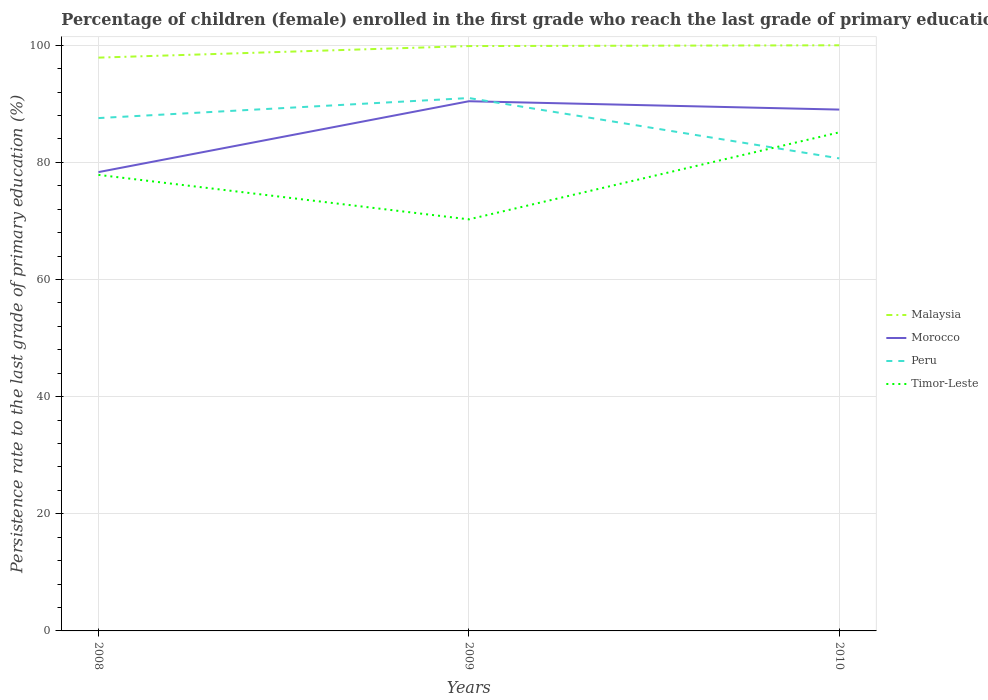Does the line corresponding to Peru intersect with the line corresponding to Malaysia?
Provide a succinct answer. No. Across all years, what is the maximum persistence rate of children in Morocco?
Provide a succinct answer. 78.34. What is the total persistence rate of children in Timor-Leste in the graph?
Provide a succinct answer. -14.86. What is the difference between the highest and the second highest persistence rate of children in Peru?
Your answer should be very brief. 10.3. What is the difference between the highest and the lowest persistence rate of children in Peru?
Provide a short and direct response. 2. Is the persistence rate of children in Peru strictly greater than the persistence rate of children in Morocco over the years?
Ensure brevity in your answer.  No. How many lines are there?
Ensure brevity in your answer.  4. Does the graph contain any zero values?
Provide a short and direct response. No. Where does the legend appear in the graph?
Provide a succinct answer. Center right. How many legend labels are there?
Ensure brevity in your answer.  4. How are the legend labels stacked?
Your answer should be compact. Vertical. What is the title of the graph?
Offer a very short reply. Percentage of children (female) enrolled in the first grade who reach the last grade of primary education. What is the label or title of the X-axis?
Your answer should be very brief. Years. What is the label or title of the Y-axis?
Give a very brief answer. Persistence rate to the last grade of primary education (%). What is the Persistence rate to the last grade of primary education (%) of Malaysia in 2008?
Give a very brief answer. 97.89. What is the Persistence rate to the last grade of primary education (%) of Morocco in 2008?
Your answer should be very brief. 78.34. What is the Persistence rate to the last grade of primary education (%) of Peru in 2008?
Give a very brief answer. 87.57. What is the Persistence rate to the last grade of primary education (%) of Timor-Leste in 2008?
Your answer should be compact. 77.87. What is the Persistence rate to the last grade of primary education (%) in Malaysia in 2009?
Provide a succinct answer. 99.87. What is the Persistence rate to the last grade of primary education (%) in Morocco in 2009?
Provide a short and direct response. 90.44. What is the Persistence rate to the last grade of primary education (%) of Peru in 2009?
Make the answer very short. 90.99. What is the Persistence rate to the last grade of primary education (%) in Timor-Leste in 2009?
Offer a terse response. 70.28. What is the Persistence rate to the last grade of primary education (%) of Morocco in 2010?
Your response must be concise. 89.02. What is the Persistence rate to the last grade of primary education (%) in Peru in 2010?
Offer a terse response. 80.69. What is the Persistence rate to the last grade of primary education (%) in Timor-Leste in 2010?
Make the answer very short. 85.14. Across all years, what is the maximum Persistence rate to the last grade of primary education (%) in Morocco?
Your response must be concise. 90.44. Across all years, what is the maximum Persistence rate to the last grade of primary education (%) in Peru?
Make the answer very short. 90.99. Across all years, what is the maximum Persistence rate to the last grade of primary education (%) of Timor-Leste?
Your answer should be compact. 85.14. Across all years, what is the minimum Persistence rate to the last grade of primary education (%) of Malaysia?
Provide a short and direct response. 97.89. Across all years, what is the minimum Persistence rate to the last grade of primary education (%) of Morocco?
Your answer should be very brief. 78.34. Across all years, what is the minimum Persistence rate to the last grade of primary education (%) in Peru?
Keep it short and to the point. 80.69. Across all years, what is the minimum Persistence rate to the last grade of primary education (%) in Timor-Leste?
Ensure brevity in your answer.  70.28. What is the total Persistence rate to the last grade of primary education (%) in Malaysia in the graph?
Give a very brief answer. 297.76. What is the total Persistence rate to the last grade of primary education (%) in Morocco in the graph?
Keep it short and to the point. 257.81. What is the total Persistence rate to the last grade of primary education (%) in Peru in the graph?
Keep it short and to the point. 259.25. What is the total Persistence rate to the last grade of primary education (%) in Timor-Leste in the graph?
Offer a terse response. 233.28. What is the difference between the Persistence rate to the last grade of primary education (%) in Malaysia in 2008 and that in 2009?
Provide a succinct answer. -1.97. What is the difference between the Persistence rate to the last grade of primary education (%) in Morocco in 2008 and that in 2009?
Offer a very short reply. -12.1. What is the difference between the Persistence rate to the last grade of primary education (%) in Peru in 2008 and that in 2009?
Keep it short and to the point. -3.42. What is the difference between the Persistence rate to the last grade of primary education (%) in Timor-Leste in 2008 and that in 2009?
Make the answer very short. 7.6. What is the difference between the Persistence rate to the last grade of primary education (%) of Malaysia in 2008 and that in 2010?
Ensure brevity in your answer.  -2.11. What is the difference between the Persistence rate to the last grade of primary education (%) of Morocco in 2008 and that in 2010?
Your answer should be compact. -10.68. What is the difference between the Persistence rate to the last grade of primary education (%) in Peru in 2008 and that in 2010?
Offer a terse response. 6.88. What is the difference between the Persistence rate to the last grade of primary education (%) in Timor-Leste in 2008 and that in 2010?
Your response must be concise. -7.26. What is the difference between the Persistence rate to the last grade of primary education (%) in Malaysia in 2009 and that in 2010?
Give a very brief answer. -0.13. What is the difference between the Persistence rate to the last grade of primary education (%) in Morocco in 2009 and that in 2010?
Your answer should be very brief. 1.42. What is the difference between the Persistence rate to the last grade of primary education (%) in Peru in 2009 and that in 2010?
Offer a terse response. 10.3. What is the difference between the Persistence rate to the last grade of primary education (%) of Timor-Leste in 2009 and that in 2010?
Keep it short and to the point. -14.86. What is the difference between the Persistence rate to the last grade of primary education (%) of Malaysia in 2008 and the Persistence rate to the last grade of primary education (%) of Morocco in 2009?
Provide a short and direct response. 7.45. What is the difference between the Persistence rate to the last grade of primary education (%) of Malaysia in 2008 and the Persistence rate to the last grade of primary education (%) of Peru in 2009?
Provide a succinct answer. 6.9. What is the difference between the Persistence rate to the last grade of primary education (%) in Malaysia in 2008 and the Persistence rate to the last grade of primary education (%) in Timor-Leste in 2009?
Make the answer very short. 27.62. What is the difference between the Persistence rate to the last grade of primary education (%) of Morocco in 2008 and the Persistence rate to the last grade of primary education (%) of Peru in 2009?
Keep it short and to the point. -12.65. What is the difference between the Persistence rate to the last grade of primary education (%) of Morocco in 2008 and the Persistence rate to the last grade of primary education (%) of Timor-Leste in 2009?
Provide a short and direct response. 8.07. What is the difference between the Persistence rate to the last grade of primary education (%) in Peru in 2008 and the Persistence rate to the last grade of primary education (%) in Timor-Leste in 2009?
Give a very brief answer. 17.29. What is the difference between the Persistence rate to the last grade of primary education (%) in Malaysia in 2008 and the Persistence rate to the last grade of primary education (%) in Morocco in 2010?
Ensure brevity in your answer.  8.87. What is the difference between the Persistence rate to the last grade of primary education (%) in Malaysia in 2008 and the Persistence rate to the last grade of primary education (%) in Peru in 2010?
Your response must be concise. 17.2. What is the difference between the Persistence rate to the last grade of primary education (%) in Malaysia in 2008 and the Persistence rate to the last grade of primary education (%) in Timor-Leste in 2010?
Make the answer very short. 12.76. What is the difference between the Persistence rate to the last grade of primary education (%) of Morocco in 2008 and the Persistence rate to the last grade of primary education (%) of Peru in 2010?
Your response must be concise. -2.35. What is the difference between the Persistence rate to the last grade of primary education (%) of Morocco in 2008 and the Persistence rate to the last grade of primary education (%) of Timor-Leste in 2010?
Your answer should be compact. -6.79. What is the difference between the Persistence rate to the last grade of primary education (%) in Peru in 2008 and the Persistence rate to the last grade of primary education (%) in Timor-Leste in 2010?
Provide a short and direct response. 2.43. What is the difference between the Persistence rate to the last grade of primary education (%) of Malaysia in 2009 and the Persistence rate to the last grade of primary education (%) of Morocco in 2010?
Offer a terse response. 10.85. What is the difference between the Persistence rate to the last grade of primary education (%) in Malaysia in 2009 and the Persistence rate to the last grade of primary education (%) in Peru in 2010?
Your response must be concise. 19.18. What is the difference between the Persistence rate to the last grade of primary education (%) in Malaysia in 2009 and the Persistence rate to the last grade of primary education (%) in Timor-Leste in 2010?
Provide a short and direct response. 14.73. What is the difference between the Persistence rate to the last grade of primary education (%) in Morocco in 2009 and the Persistence rate to the last grade of primary education (%) in Peru in 2010?
Provide a short and direct response. 9.76. What is the difference between the Persistence rate to the last grade of primary education (%) in Morocco in 2009 and the Persistence rate to the last grade of primary education (%) in Timor-Leste in 2010?
Give a very brief answer. 5.31. What is the difference between the Persistence rate to the last grade of primary education (%) in Peru in 2009 and the Persistence rate to the last grade of primary education (%) in Timor-Leste in 2010?
Offer a very short reply. 5.86. What is the average Persistence rate to the last grade of primary education (%) of Malaysia per year?
Your answer should be very brief. 99.25. What is the average Persistence rate to the last grade of primary education (%) in Morocco per year?
Your response must be concise. 85.94. What is the average Persistence rate to the last grade of primary education (%) of Peru per year?
Make the answer very short. 86.42. What is the average Persistence rate to the last grade of primary education (%) of Timor-Leste per year?
Make the answer very short. 77.76. In the year 2008, what is the difference between the Persistence rate to the last grade of primary education (%) of Malaysia and Persistence rate to the last grade of primary education (%) of Morocco?
Keep it short and to the point. 19.55. In the year 2008, what is the difference between the Persistence rate to the last grade of primary education (%) of Malaysia and Persistence rate to the last grade of primary education (%) of Peru?
Make the answer very short. 10.32. In the year 2008, what is the difference between the Persistence rate to the last grade of primary education (%) of Malaysia and Persistence rate to the last grade of primary education (%) of Timor-Leste?
Keep it short and to the point. 20.02. In the year 2008, what is the difference between the Persistence rate to the last grade of primary education (%) in Morocco and Persistence rate to the last grade of primary education (%) in Peru?
Your answer should be compact. -9.23. In the year 2008, what is the difference between the Persistence rate to the last grade of primary education (%) in Morocco and Persistence rate to the last grade of primary education (%) in Timor-Leste?
Offer a very short reply. 0.47. In the year 2008, what is the difference between the Persistence rate to the last grade of primary education (%) of Peru and Persistence rate to the last grade of primary education (%) of Timor-Leste?
Your response must be concise. 9.7. In the year 2009, what is the difference between the Persistence rate to the last grade of primary education (%) of Malaysia and Persistence rate to the last grade of primary education (%) of Morocco?
Make the answer very short. 9.42. In the year 2009, what is the difference between the Persistence rate to the last grade of primary education (%) in Malaysia and Persistence rate to the last grade of primary education (%) in Peru?
Ensure brevity in your answer.  8.87. In the year 2009, what is the difference between the Persistence rate to the last grade of primary education (%) in Malaysia and Persistence rate to the last grade of primary education (%) in Timor-Leste?
Your answer should be very brief. 29.59. In the year 2009, what is the difference between the Persistence rate to the last grade of primary education (%) in Morocco and Persistence rate to the last grade of primary education (%) in Peru?
Offer a very short reply. -0.55. In the year 2009, what is the difference between the Persistence rate to the last grade of primary education (%) of Morocco and Persistence rate to the last grade of primary education (%) of Timor-Leste?
Provide a short and direct response. 20.17. In the year 2009, what is the difference between the Persistence rate to the last grade of primary education (%) of Peru and Persistence rate to the last grade of primary education (%) of Timor-Leste?
Provide a short and direct response. 20.72. In the year 2010, what is the difference between the Persistence rate to the last grade of primary education (%) of Malaysia and Persistence rate to the last grade of primary education (%) of Morocco?
Give a very brief answer. 10.98. In the year 2010, what is the difference between the Persistence rate to the last grade of primary education (%) of Malaysia and Persistence rate to the last grade of primary education (%) of Peru?
Give a very brief answer. 19.31. In the year 2010, what is the difference between the Persistence rate to the last grade of primary education (%) of Malaysia and Persistence rate to the last grade of primary education (%) of Timor-Leste?
Your answer should be very brief. 14.86. In the year 2010, what is the difference between the Persistence rate to the last grade of primary education (%) of Morocco and Persistence rate to the last grade of primary education (%) of Peru?
Your answer should be compact. 8.33. In the year 2010, what is the difference between the Persistence rate to the last grade of primary education (%) of Morocco and Persistence rate to the last grade of primary education (%) of Timor-Leste?
Make the answer very short. 3.88. In the year 2010, what is the difference between the Persistence rate to the last grade of primary education (%) of Peru and Persistence rate to the last grade of primary education (%) of Timor-Leste?
Provide a succinct answer. -4.45. What is the ratio of the Persistence rate to the last grade of primary education (%) of Malaysia in 2008 to that in 2009?
Make the answer very short. 0.98. What is the ratio of the Persistence rate to the last grade of primary education (%) of Morocco in 2008 to that in 2009?
Offer a terse response. 0.87. What is the ratio of the Persistence rate to the last grade of primary education (%) of Peru in 2008 to that in 2009?
Make the answer very short. 0.96. What is the ratio of the Persistence rate to the last grade of primary education (%) of Timor-Leste in 2008 to that in 2009?
Keep it short and to the point. 1.11. What is the ratio of the Persistence rate to the last grade of primary education (%) in Malaysia in 2008 to that in 2010?
Your answer should be compact. 0.98. What is the ratio of the Persistence rate to the last grade of primary education (%) of Morocco in 2008 to that in 2010?
Provide a short and direct response. 0.88. What is the ratio of the Persistence rate to the last grade of primary education (%) of Peru in 2008 to that in 2010?
Keep it short and to the point. 1.09. What is the ratio of the Persistence rate to the last grade of primary education (%) of Timor-Leste in 2008 to that in 2010?
Provide a succinct answer. 0.91. What is the ratio of the Persistence rate to the last grade of primary education (%) of Morocco in 2009 to that in 2010?
Your answer should be very brief. 1.02. What is the ratio of the Persistence rate to the last grade of primary education (%) of Peru in 2009 to that in 2010?
Give a very brief answer. 1.13. What is the ratio of the Persistence rate to the last grade of primary education (%) in Timor-Leste in 2009 to that in 2010?
Offer a terse response. 0.83. What is the difference between the highest and the second highest Persistence rate to the last grade of primary education (%) of Malaysia?
Your answer should be compact. 0.13. What is the difference between the highest and the second highest Persistence rate to the last grade of primary education (%) in Morocco?
Your response must be concise. 1.42. What is the difference between the highest and the second highest Persistence rate to the last grade of primary education (%) in Peru?
Provide a short and direct response. 3.42. What is the difference between the highest and the second highest Persistence rate to the last grade of primary education (%) of Timor-Leste?
Ensure brevity in your answer.  7.26. What is the difference between the highest and the lowest Persistence rate to the last grade of primary education (%) in Malaysia?
Your answer should be compact. 2.11. What is the difference between the highest and the lowest Persistence rate to the last grade of primary education (%) in Morocco?
Offer a very short reply. 12.1. What is the difference between the highest and the lowest Persistence rate to the last grade of primary education (%) of Peru?
Give a very brief answer. 10.3. What is the difference between the highest and the lowest Persistence rate to the last grade of primary education (%) of Timor-Leste?
Provide a succinct answer. 14.86. 